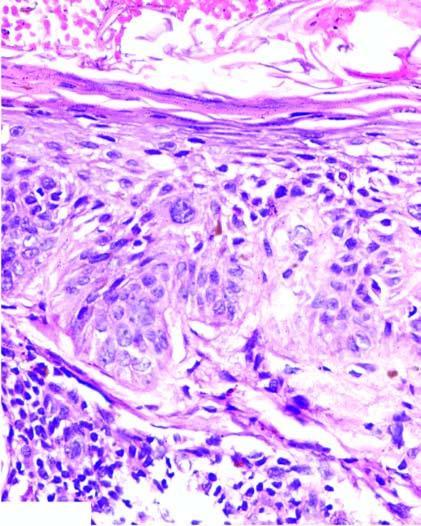s the cut surface not breached?
Answer the question using a single word or phrase. No 